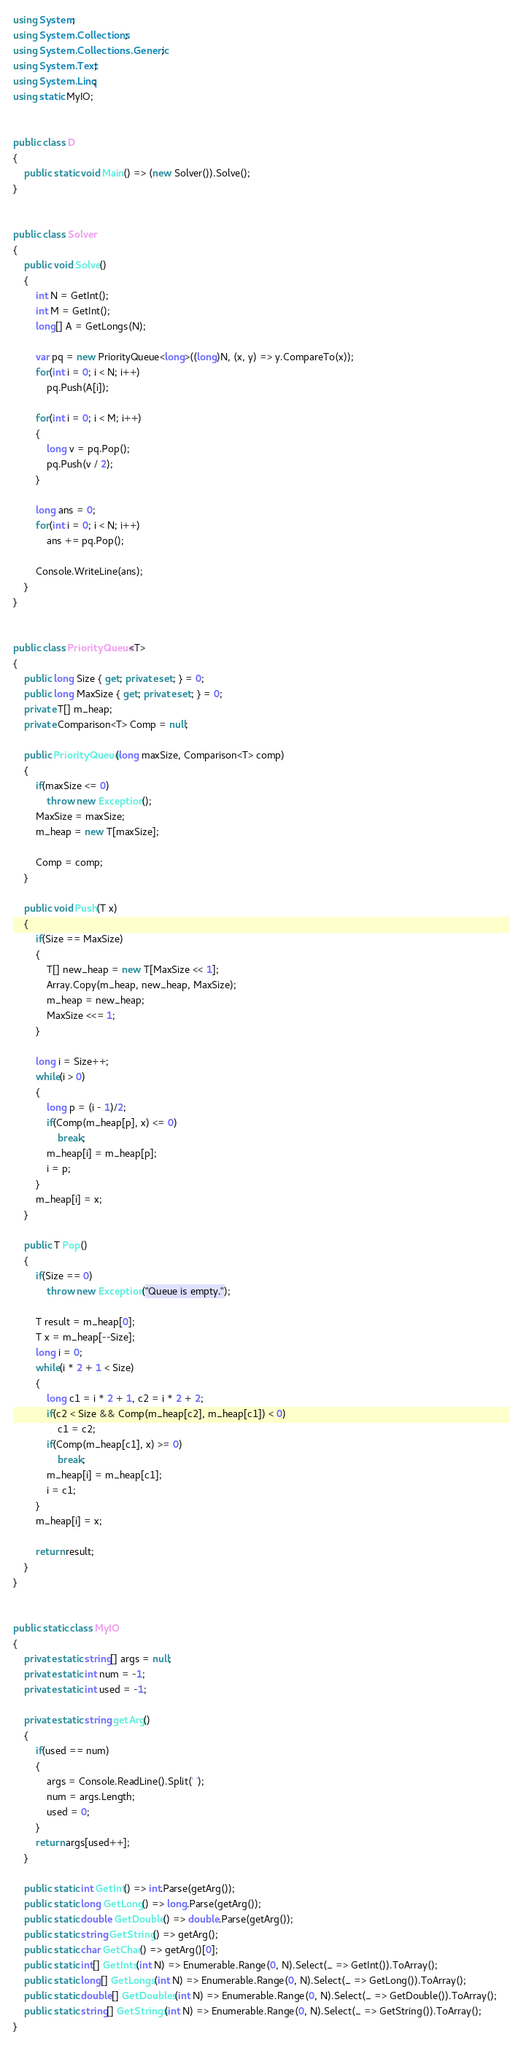Convert code to text. <code><loc_0><loc_0><loc_500><loc_500><_C#_>using System;
using System.Collections;
using System.Collections.Generic;
using System.Text;
using System.Linq;
using static MyIO;


public class D
{
	public static void Main() => (new Solver()).Solve();
}


public class Solver
{
	public void Solve()
	{
		int N = GetInt();
		int M = GetInt();
		long[] A = GetLongs(N);

		var pq = new PriorityQueue<long>((long)N, (x, y) => y.CompareTo(x));
		for(int i = 0; i < N; i++)
			pq.Push(A[i]);

		for(int i = 0; i < M; i++)
		{
			long v = pq.Pop();
			pq.Push(v / 2);
		}

		long ans = 0;
		for(int i = 0; i < N; i++)
			ans += pq.Pop();

		Console.WriteLine(ans);
	}
}


public class PriorityQueue<T>
{
	public long Size { get; private set; } = 0;
	public long MaxSize { get; private set; } = 0;
	private T[] m_heap;
	private Comparison<T> Comp = null;
	
	public PriorityQueue(long maxSize, Comparison<T> comp)
	{
		if(maxSize <= 0)
			throw new Exception();
		MaxSize = maxSize;
		m_heap = new T[maxSize];

		Comp = comp;
	}
	
	public void Push(T x)
	{
		if(Size == MaxSize)
		{
			T[] new_heap = new T[MaxSize << 1];
			Array.Copy(m_heap, new_heap, MaxSize);
			m_heap = new_heap;
			MaxSize <<= 1;
		}
		
		long i = Size++;
		while(i > 0)
		{
			long p = (i - 1)/2;
			if(Comp(m_heap[p], x) <= 0)
				break;
			m_heap[i] = m_heap[p];
			i = p;			
		}
		m_heap[i] = x;		
	}
	
	public T Pop()
	{
		if(Size == 0)
			throw new Exception("Queue is empty.");
		
		T result = m_heap[0];
		T x = m_heap[--Size];
		long i = 0;
		while(i * 2 + 1 < Size)
		{
			long c1 = i * 2 + 1, c2 = i * 2 + 2;
			if(c2 < Size && Comp(m_heap[c2], m_heap[c1]) < 0)
				c1 = c2;
			if(Comp(m_heap[c1], x) >= 0)
				break;
			m_heap[i] = m_heap[c1];
			i = c1;
		}
		m_heap[i] = x;
		
		return result;		
	}	
}


public static class MyIO
{
	private static string[] args = null;
	private static int num = -1;
	private static int used = -1;

	private static string getArg()
	{
		if(used == num)
		{
			args = Console.ReadLine().Split(' ');
			num = args.Length;
			used = 0;
		}
		return args[used++];
	}

	public static int GetInt() => int.Parse(getArg());
	public static long GetLong() => long.Parse(getArg());
	public static double GetDouble() => double.Parse(getArg());
	public static string GetString() => getArg();
	public static char GetChar() => getArg()[0];
	public static int[] GetInts(int N) => Enumerable.Range(0, N).Select(_ => GetInt()).ToArray();
	public static long[] GetLongs(int N) => Enumerable.Range(0, N).Select(_ => GetLong()).ToArray();
	public static double[] GetDoubles(int N) => Enumerable.Range(0, N).Select(_ => GetDouble()).ToArray();
	public static string[] GetStrings(int N) => Enumerable.Range(0, N).Select(_ => GetString()).ToArray();
}
</code> 